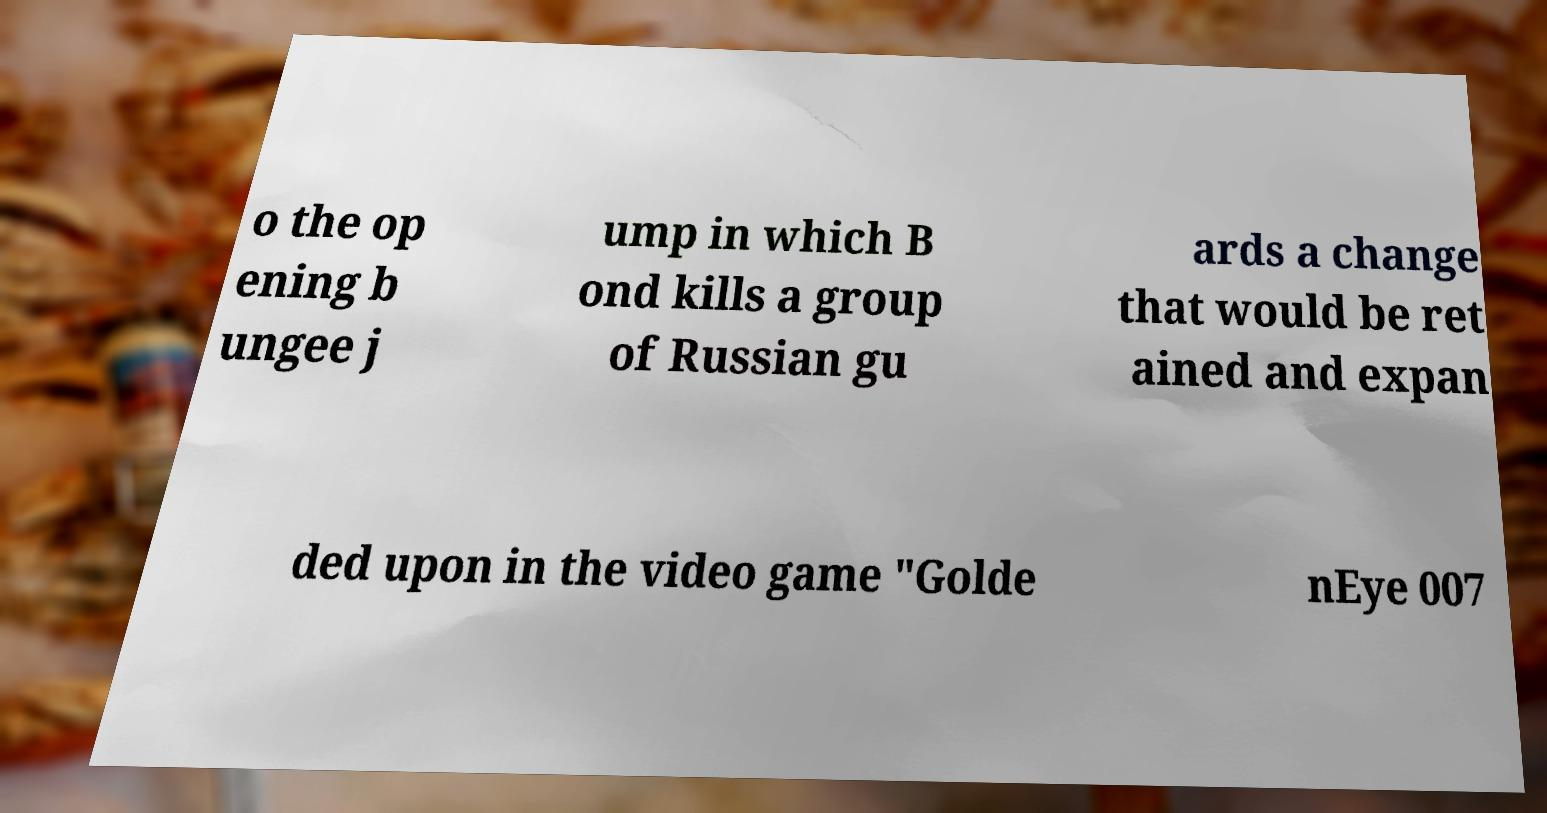I need the written content from this picture converted into text. Can you do that? o the op ening b ungee j ump in which B ond kills a group of Russian gu ards a change that would be ret ained and expan ded upon in the video game "Golde nEye 007 